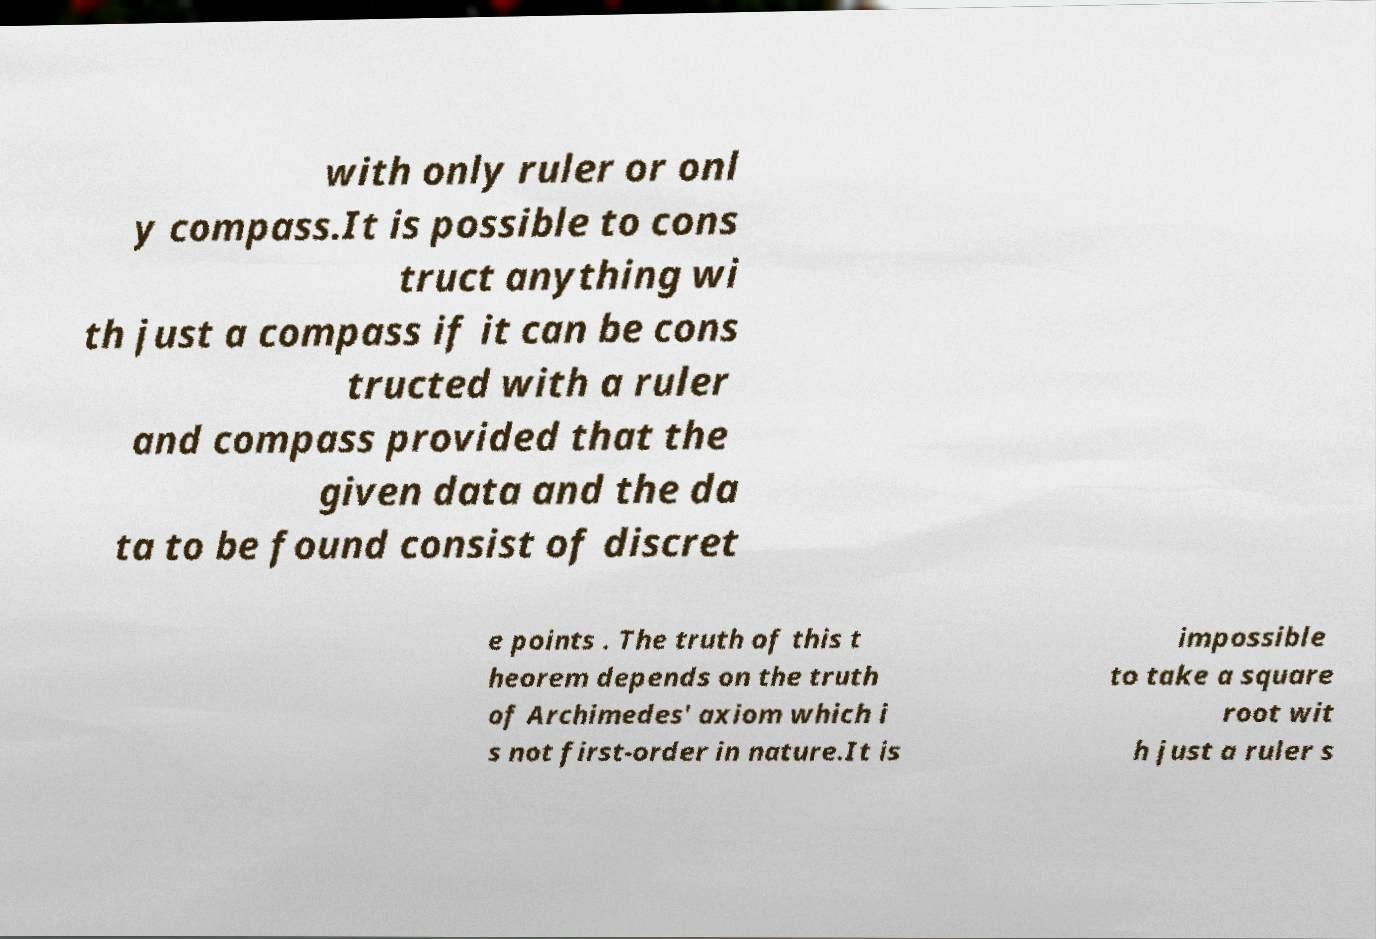Could you assist in decoding the text presented in this image and type it out clearly? with only ruler or onl y compass.It is possible to cons truct anything wi th just a compass if it can be cons tructed with a ruler and compass provided that the given data and the da ta to be found consist of discret e points . The truth of this t heorem depends on the truth of Archimedes' axiom which i s not first-order in nature.It is impossible to take a square root wit h just a ruler s 